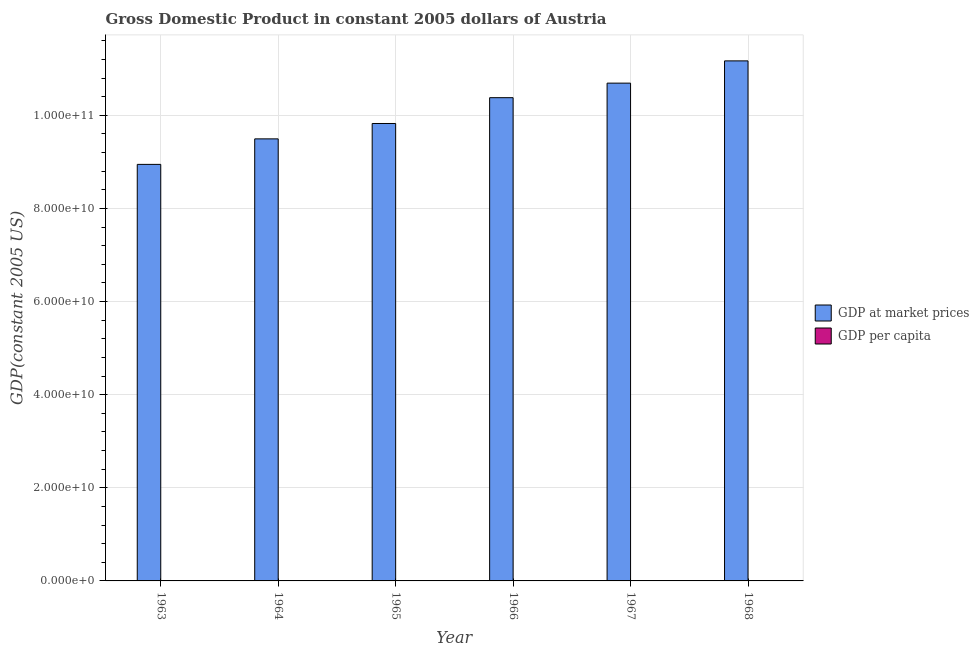How many different coloured bars are there?
Your answer should be very brief. 2. How many groups of bars are there?
Your answer should be very brief. 6. Are the number of bars per tick equal to the number of legend labels?
Provide a succinct answer. Yes. How many bars are there on the 3rd tick from the left?
Offer a terse response. 2. How many bars are there on the 1st tick from the right?
Offer a very short reply. 2. What is the label of the 5th group of bars from the left?
Make the answer very short. 1967. In how many cases, is the number of bars for a given year not equal to the number of legend labels?
Your response must be concise. 0. What is the gdp per capita in 1965?
Your answer should be compact. 1.35e+04. Across all years, what is the maximum gdp at market prices?
Keep it short and to the point. 1.12e+11. Across all years, what is the minimum gdp per capita?
Give a very brief answer. 1.25e+04. In which year was the gdp at market prices maximum?
Your answer should be very brief. 1968. In which year was the gdp per capita minimum?
Your answer should be very brief. 1963. What is the total gdp per capita in the graph?
Your answer should be very brief. 8.29e+04. What is the difference between the gdp per capita in 1964 and that in 1967?
Your answer should be compact. -1349.83. What is the difference between the gdp at market prices in 1963 and the gdp per capita in 1968?
Offer a terse response. -2.22e+1. What is the average gdp at market prices per year?
Ensure brevity in your answer.  1.01e+11. What is the ratio of the gdp at market prices in 1965 to that in 1967?
Provide a succinct answer. 0.92. Is the gdp at market prices in 1965 less than that in 1967?
Ensure brevity in your answer.  Yes. What is the difference between the highest and the second highest gdp at market prices?
Ensure brevity in your answer.  4.78e+09. What is the difference between the highest and the lowest gdp at market prices?
Keep it short and to the point. 2.22e+1. What does the 2nd bar from the left in 1967 represents?
Offer a very short reply. GDP per capita. What does the 2nd bar from the right in 1965 represents?
Keep it short and to the point. GDP at market prices. How many bars are there?
Give a very brief answer. 12. Are all the bars in the graph horizontal?
Your response must be concise. No. Does the graph contain grids?
Provide a short and direct response. Yes. Where does the legend appear in the graph?
Offer a terse response. Center right. What is the title of the graph?
Make the answer very short. Gross Domestic Product in constant 2005 dollars of Austria. What is the label or title of the Y-axis?
Keep it short and to the point. GDP(constant 2005 US). What is the GDP(constant 2005 US) of GDP at market prices in 1963?
Offer a very short reply. 8.95e+1. What is the GDP(constant 2005 US) in GDP per capita in 1963?
Your response must be concise. 1.25e+04. What is the GDP(constant 2005 US) in GDP at market prices in 1964?
Your answer should be compact. 9.50e+1. What is the GDP(constant 2005 US) of GDP per capita in 1964?
Provide a short and direct response. 1.31e+04. What is the GDP(constant 2005 US) of GDP at market prices in 1965?
Your response must be concise. 9.83e+1. What is the GDP(constant 2005 US) in GDP per capita in 1965?
Provide a succinct answer. 1.35e+04. What is the GDP(constant 2005 US) in GDP at market prices in 1966?
Your answer should be compact. 1.04e+11. What is the GDP(constant 2005 US) in GDP per capita in 1966?
Provide a succinct answer. 1.42e+04. What is the GDP(constant 2005 US) of GDP at market prices in 1967?
Keep it short and to the point. 1.07e+11. What is the GDP(constant 2005 US) in GDP per capita in 1967?
Offer a very short reply. 1.45e+04. What is the GDP(constant 2005 US) in GDP at market prices in 1968?
Make the answer very short. 1.12e+11. What is the GDP(constant 2005 US) in GDP per capita in 1968?
Provide a succinct answer. 1.51e+04. Across all years, what is the maximum GDP(constant 2005 US) in GDP at market prices?
Make the answer very short. 1.12e+11. Across all years, what is the maximum GDP(constant 2005 US) of GDP per capita?
Your answer should be very brief. 1.51e+04. Across all years, what is the minimum GDP(constant 2005 US) of GDP at market prices?
Your response must be concise. 8.95e+1. Across all years, what is the minimum GDP(constant 2005 US) of GDP per capita?
Offer a very short reply. 1.25e+04. What is the total GDP(constant 2005 US) in GDP at market prices in the graph?
Make the answer very short. 6.05e+11. What is the total GDP(constant 2005 US) in GDP per capita in the graph?
Make the answer very short. 8.29e+04. What is the difference between the GDP(constant 2005 US) of GDP at market prices in 1963 and that in 1964?
Your answer should be very brief. -5.48e+09. What is the difference between the GDP(constant 2005 US) of GDP per capita in 1963 and that in 1964?
Ensure brevity in your answer.  -675.72. What is the difference between the GDP(constant 2005 US) in GDP at market prices in 1963 and that in 1965?
Your answer should be very brief. -8.78e+09. What is the difference between the GDP(constant 2005 US) in GDP per capita in 1963 and that in 1965?
Give a very brief answer. -1045.07. What is the difference between the GDP(constant 2005 US) of GDP at market prices in 1963 and that in 1966?
Provide a succinct answer. -1.43e+1. What is the difference between the GDP(constant 2005 US) of GDP per capita in 1963 and that in 1966?
Ensure brevity in your answer.  -1707.85. What is the difference between the GDP(constant 2005 US) of GDP at market prices in 1963 and that in 1967?
Provide a succinct answer. -1.75e+1. What is the difference between the GDP(constant 2005 US) of GDP per capita in 1963 and that in 1967?
Your answer should be compact. -2025.55. What is the difference between the GDP(constant 2005 US) in GDP at market prices in 1963 and that in 1968?
Offer a terse response. -2.22e+1. What is the difference between the GDP(constant 2005 US) in GDP per capita in 1963 and that in 1968?
Ensure brevity in your answer.  -2595.35. What is the difference between the GDP(constant 2005 US) of GDP at market prices in 1964 and that in 1965?
Your answer should be very brief. -3.30e+09. What is the difference between the GDP(constant 2005 US) of GDP per capita in 1964 and that in 1965?
Give a very brief answer. -369.36. What is the difference between the GDP(constant 2005 US) in GDP at market prices in 1964 and that in 1966?
Keep it short and to the point. -8.85e+09. What is the difference between the GDP(constant 2005 US) of GDP per capita in 1964 and that in 1966?
Your response must be concise. -1032.13. What is the difference between the GDP(constant 2005 US) in GDP at market prices in 1964 and that in 1967?
Offer a very short reply. -1.20e+1. What is the difference between the GDP(constant 2005 US) in GDP per capita in 1964 and that in 1967?
Provide a short and direct response. -1349.83. What is the difference between the GDP(constant 2005 US) in GDP at market prices in 1964 and that in 1968?
Offer a terse response. -1.68e+1. What is the difference between the GDP(constant 2005 US) in GDP per capita in 1964 and that in 1968?
Ensure brevity in your answer.  -1919.63. What is the difference between the GDP(constant 2005 US) in GDP at market prices in 1965 and that in 1966?
Keep it short and to the point. -5.54e+09. What is the difference between the GDP(constant 2005 US) in GDP per capita in 1965 and that in 1966?
Provide a succinct answer. -662.78. What is the difference between the GDP(constant 2005 US) in GDP at market prices in 1965 and that in 1967?
Provide a succinct answer. -8.67e+09. What is the difference between the GDP(constant 2005 US) in GDP per capita in 1965 and that in 1967?
Your answer should be very brief. -980.47. What is the difference between the GDP(constant 2005 US) in GDP at market prices in 1965 and that in 1968?
Offer a terse response. -1.34e+1. What is the difference between the GDP(constant 2005 US) in GDP per capita in 1965 and that in 1968?
Offer a terse response. -1550.27. What is the difference between the GDP(constant 2005 US) in GDP at market prices in 1966 and that in 1967?
Make the answer very short. -3.12e+09. What is the difference between the GDP(constant 2005 US) in GDP per capita in 1966 and that in 1967?
Your answer should be compact. -317.7. What is the difference between the GDP(constant 2005 US) of GDP at market prices in 1966 and that in 1968?
Offer a terse response. -7.90e+09. What is the difference between the GDP(constant 2005 US) in GDP per capita in 1966 and that in 1968?
Offer a very short reply. -887.5. What is the difference between the GDP(constant 2005 US) of GDP at market prices in 1967 and that in 1968?
Give a very brief answer. -4.78e+09. What is the difference between the GDP(constant 2005 US) in GDP per capita in 1967 and that in 1968?
Offer a very short reply. -569.8. What is the difference between the GDP(constant 2005 US) of GDP at market prices in 1963 and the GDP(constant 2005 US) of GDP per capita in 1964?
Your answer should be compact. 8.95e+1. What is the difference between the GDP(constant 2005 US) of GDP at market prices in 1963 and the GDP(constant 2005 US) of GDP per capita in 1965?
Your answer should be compact. 8.95e+1. What is the difference between the GDP(constant 2005 US) of GDP at market prices in 1963 and the GDP(constant 2005 US) of GDP per capita in 1966?
Ensure brevity in your answer.  8.95e+1. What is the difference between the GDP(constant 2005 US) of GDP at market prices in 1963 and the GDP(constant 2005 US) of GDP per capita in 1967?
Ensure brevity in your answer.  8.95e+1. What is the difference between the GDP(constant 2005 US) in GDP at market prices in 1963 and the GDP(constant 2005 US) in GDP per capita in 1968?
Your answer should be very brief. 8.95e+1. What is the difference between the GDP(constant 2005 US) of GDP at market prices in 1964 and the GDP(constant 2005 US) of GDP per capita in 1965?
Your response must be concise. 9.50e+1. What is the difference between the GDP(constant 2005 US) in GDP at market prices in 1964 and the GDP(constant 2005 US) in GDP per capita in 1966?
Give a very brief answer. 9.50e+1. What is the difference between the GDP(constant 2005 US) of GDP at market prices in 1964 and the GDP(constant 2005 US) of GDP per capita in 1967?
Provide a succinct answer. 9.50e+1. What is the difference between the GDP(constant 2005 US) of GDP at market prices in 1964 and the GDP(constant 2005 US) of GDP per capita in 1968?
Your answer should be compact. 9.50e+1. What is the difference between the GDP(constant 2005 US) of GDP at market prices in 1965 and the GDP(constant 2005 US) of GDP per capita in 1966?
Offer a terse response. 9.83e+1. What is the difference between the GDP(constant 2005 US) in GDP at market prices in 1965 and the GDP(constant 2005 US) in GDP per capita in 1967?
Your response must be concise. 9.83e+1. What is the difference between the GDP(constant 2005 US) in GDP at market prices in 1965 and the GDP(constant 2005 US) in GDP per capita in 1968?
Make the answer very short. 9.83e+1. What is the difference between the GDP(constant 2005 US) of GDP at market prices in 1966 and the GDP(constant 2005 US) of GDP per capita in 1967?
Provide a short and direct response. 1.04e+11. What is the difference between the GDP(constant 2005 US) of GDP at market prices in 1966 and the GDP(constant 2005 US) of GDP per capita in 1968?
Your answer should be compact. 1.04e+11. What is the difference between the GDP(constant 2005 US) of GDP at market prices in 1967 and the GDP(constant 2005 US) of GDP per capita in 1968?
Offer a very short reply. 1.07e+11. What is the average GDP(constant 2005 US) in GDP at market prices per year?
Offer a very short reply. 1.01e+11. What is the average GDP(constant 2005 US) in GDP per capita per year?
Your response must be concise. 1.38e+04. In the year 1963, what is the difference between the GDP(constant 2005 US) in GDP at market prices and GDP(constant 2005 US) in GDP per capita?
Provide a short and direct response. 8.95e+1. In the year 1964, what is the difference between the GDP(constant 2005 US) of GDP at market prices and GDP(constant 2005 US) of GDP per capita?
Give a very brief answer. 9.50e+1. In the year 1965, what is the difference between the GDP(constant 2005 US) of GDP at market prices and GDP(constant 2005 US) of GDP per capita?
Make the answer very short. 9.83e+1. In the year 1966, what is the difference between the GDP(constant 2005 US) of GDP at market prices and GDP(constant 2005 US) of GDP per capita?
Your response must be concise. 1.04e+11. In the year 1967, what is the difference between the GDP(constant 2005 US) in GDP at market prices and GDP(constant 2005 US) in GDP per capita?
Your answer should be very brief. 1.07e+11. In the year 1968, what is the difference between the GDP(constant 2005 US) of GDP at market prices and GDP(constant 2005 US) of GDP per capita?
Give a very brief answer. 1.12e+11. What is the ratio of the GDP(constant 2005 US) in GDP at market prices in 1963 to that in 1964?
Keep it short and to the point. 0.94. What is the ratio of the GDP(constant 2005 US) in GDP per capita in 1963 to that in 1964?
Make the answer very short. 0.95. What is the ratio of the GDP(constant 2005 US) in GDP at market prices in 1963 to that in 1965?
Ensure brevity in your answer.  0.91. What is the ratio of the GDP(constant 2005 US) in GDP per capita in 1963 to that in 1965?
Your answer should be compact. 0.92. What is the ratio of the GDP(constant 2005 US) of GDP at market prices in 1963 to that in 1966?
Provide a succinct answer. 0.86. What is the ratio of the GDP(constant 2005 US) of GDP per capita in 1963 to that in 1966?
Provide a succinct answer. 0.88. What is the ratio of the GDP(constant 2005 US) in GDP at market prices in 1963 to that in 1967?
Keep it short and to the point. 0.84. What is the ratio of the GDP(constant 2005 US) in GDP per capita in 1963 to that in 1967?
Provide a short and direct response. 0.86. What is the ratio of the GDP(constant 2005 US) in GDP at market prices in 1963 to that in 1968?
Keep it short and to the point. 0.8. What is the ratio of the GDP(constant 2005 US) of GDP per capita in 1963 to that in 1968?
Make the answer very short. 0.83. What is the ratio of the GDP(constant 2005 US) of GDP at market prices in 1964 to that in 1965?
Offer a very short reply. 0.97. What is the ratio of the GDP(constant 2005 US) in GDP per capita in 1964 to that in 1965?
Your answer should be very brief. 0.97. What is the ratio of the GDP(constant 2005 US) of GDP at market prices in 1964 to that in 1966?
Provide a succinct answer. 0.91. What is the ratio of the GDP(constant 2005 US) of GDP per capita in 1964 to that in 1966?
Provide a short and direct response. 0.93. What is the ratio of the GDP(constant 2005 US) of GDP at market prices in 1964 to that in 1967?
Provide a short and direct response. 0.89. What is the ratio of the GDP(constant 2005 US) in GDP per capita in 1964 to that in 1967?
Offer a very short reply. 0.91. What is the ratio of the GDP(constant 2005 US) in GDP at market prices in 1964 to that in 1968?
Your answer should be compact. 0.85. What is the ratio of the GDP(constant 2005 US) in GDP per capita in 1964 to that in 1968?
Offer a very short reply. 0.87. What is the ratio of the GDP(constant 2005 US) in GDP at market prices in 1965 to that in 1966?
Your response must be concise. 0.95. What is the ratio of the GDP(constant 2005 US) in GDP per capita in 1965 to that in 1966?
Ensure brevity in your answer.  0.95. What is the ratio of the GDP(constant 2005 US) in GDP at market prices in 1965 to that in 1967?
Ensure brevity in your answer.  0.92. What is the ratio of the GDP(constant 2005 US) of GDP per capita in 1965 to that in 1967?
Your answer should be compact. 0.93. What is the ratio of the GDP(constant 2005 US) of GDP at market prices in 1965 to that in 1968?
Your response must be concise. 0.88. What is the ratio of the GDP(constant 2005 US) in GDP per capita in 1965 to that in 1968?
Keep it short and to the point. 0.9. What is the ratio of the GDP(constant 2005 US) of GDP at market prices in 1966 to that in 1967?
Keep it short and to the point. 0.97. What is the ratio of the GDP(constant 2005 US) in GDP per capita in 1966 to that in 1967?
Your answer should be very brief. 0.98. What is the ratio of the GDP(constant 2005 US) in GDP at market prices in 1966 to that in 1968?
Offer a very short reply. 0.93. What is the ratio of the GDP(constant 2005 US) of GDP per capita in 1966 to that in 1968?
Make the answer very short. 0.94. What is the ratio of the GDP(constant 2005 US) of GDP at market prices in 1967 to that in 1968?
Ensure brevity in your answer.  0.96. What is the ratio of the GDP(constant 2005 US) in GDP per capita in 1967 to that in 1968?
Make the answer very short. 0.96. What is the difference between the highest and the second highest GDP(constant 2005 US) of GDP at market prices?
Offer a very short reply. 4.78e+09. What is the difference between the highest and the second highest GDP(constant 2005 US) in GDP per capita?
Offer a very short reply. 569.8. What is the difference between the highest and the lowest GDP(constant 2005 US) of GDP at market prices?
Your response must be concise. 2.22e+1. What is the difference between the highest and the lowest GDP(constant 2005 US) in GDP per capita?
Offer a terse response. 2595.35. 